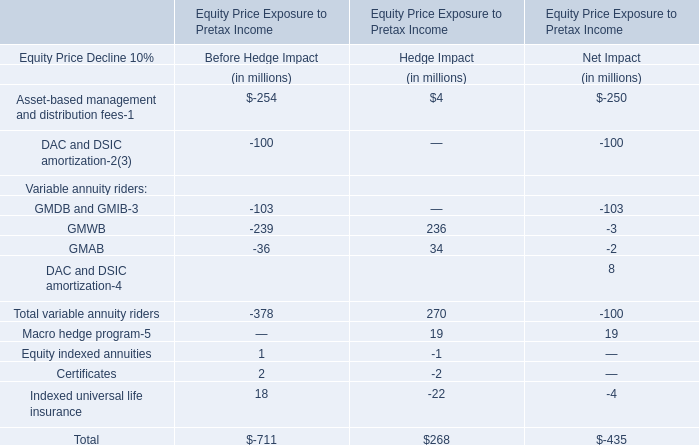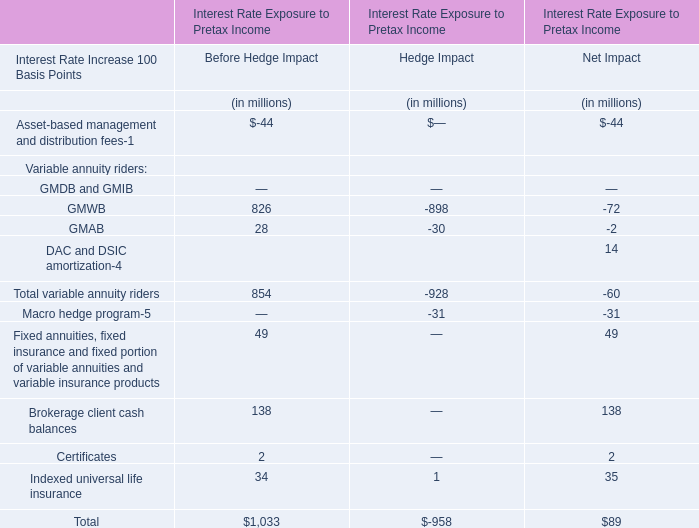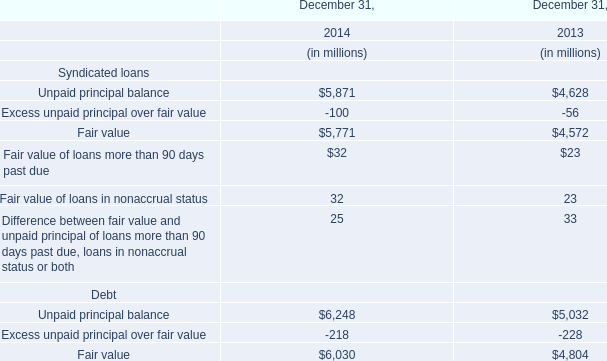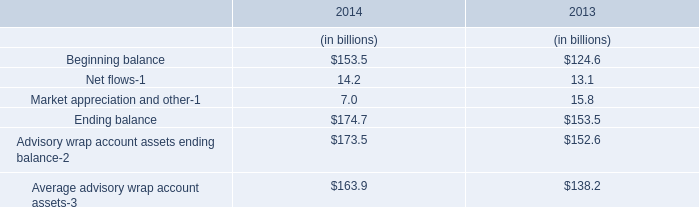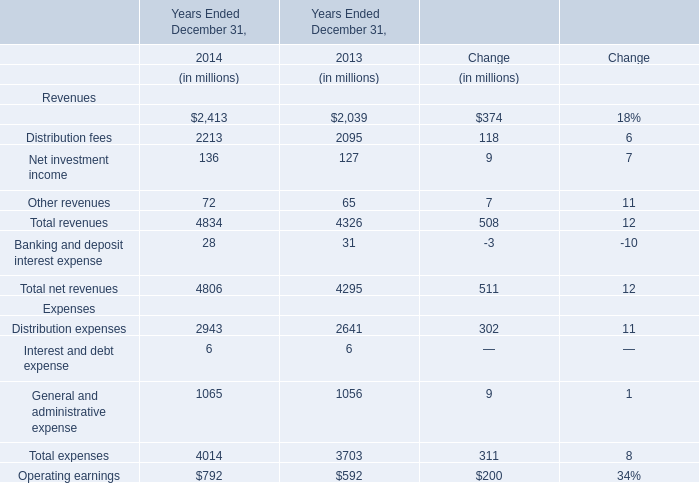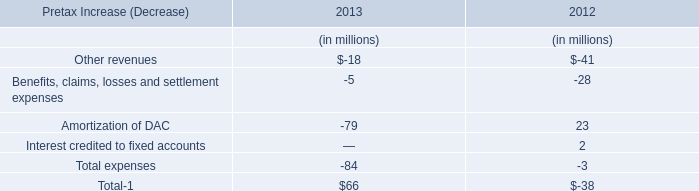What is the difference between the greatest Ending balance in 2014 and 2013？ (in millions) 
Computations: (174.7 - 153.5)
Answer: 21.2. 